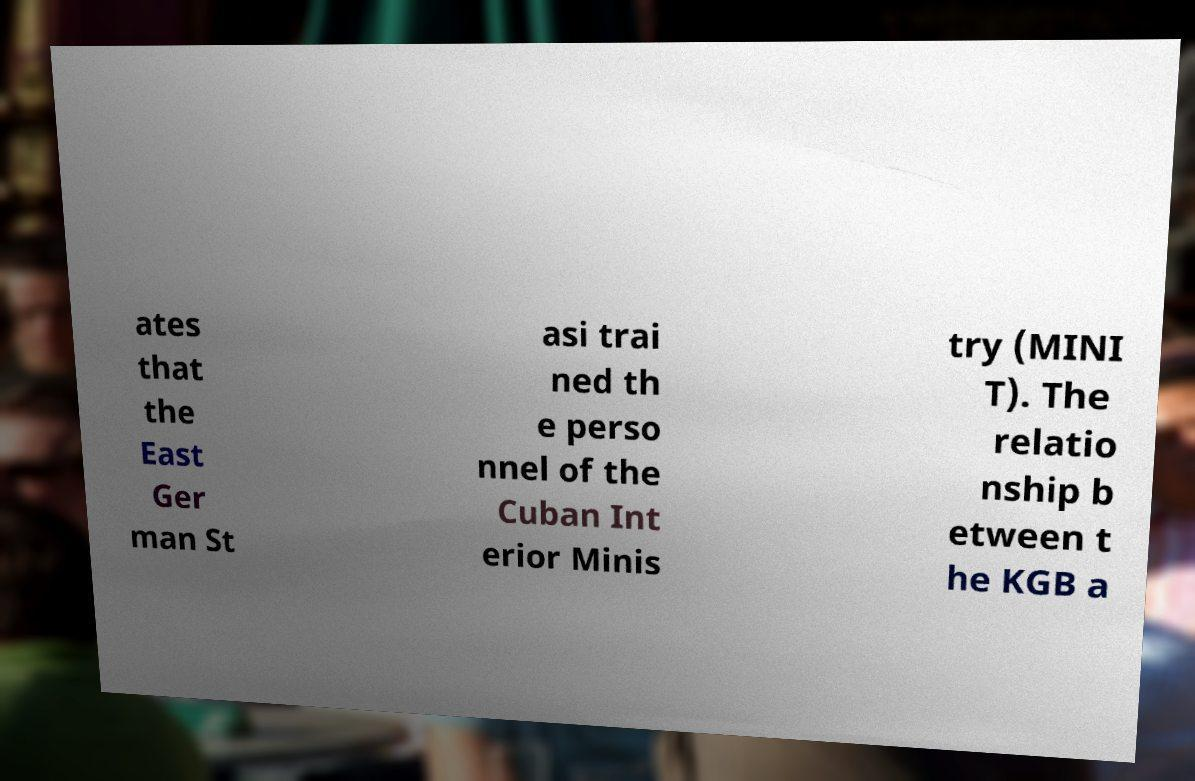What messages or text are displayed in this image? I need them in a readable, typed format. ates that the East Ger man St asi trai ned th e perso nnel of the Cuban Int erior Minis try (MINI T). The relatio nship b etween t he KGB a 